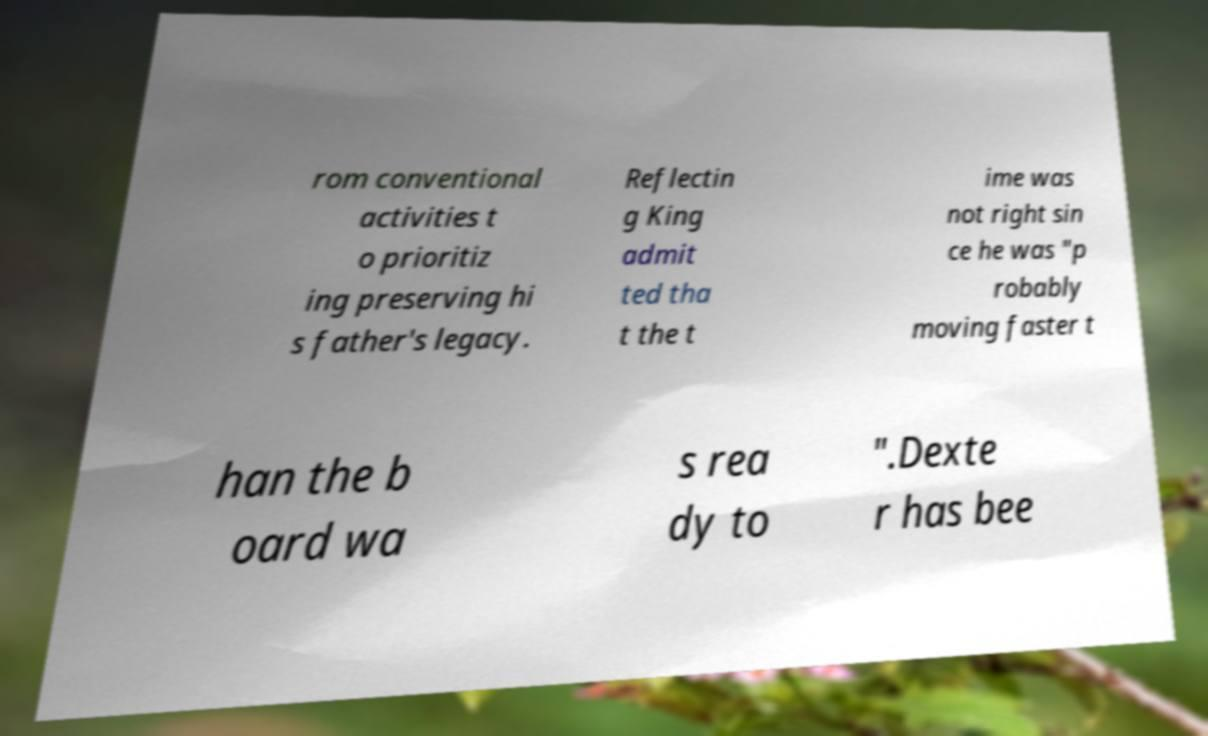Can you accurately transcribe the text from the provided image for me? rom conventional activities t o prioritiz ing preserving hi s father's legacy. Reflectin g King admit ted tha t the t ime was not right sin ce he was "p robably moving faster t han the b oard wa s rea dy to ".Dexte r has bee 